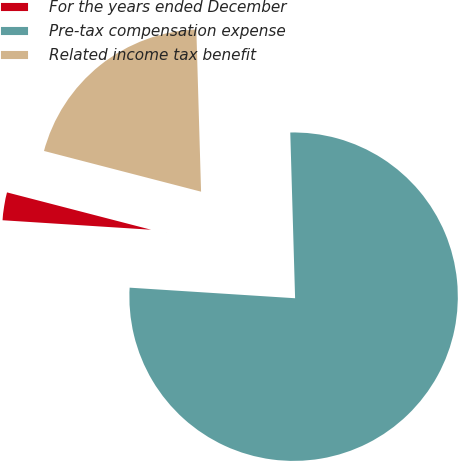Convert chart to OTSL. <chart><loc_0><loc_0><loc_500><loc_500><pie_chart><fcel>For the years ended December<fcel>Pre-tax compensation expense<fcel>Related income tax benefit<nl><fcel>3.02%<fcel>76.48%<fcel>20.5%<nl></chart> 